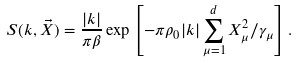<formula> <loc_0><loc_0><loc_500><loc_500>S ( k , \vec { X } ) = \frac { | k | } { \pi \beta } \exp \left [ - \pi \rho _ { 0 } | k | \sum _ { \mu = 1 } ^ { d } X _ { \mu } ^ { 2 } / \gamma _ { \mu } \right ] .</formula> 